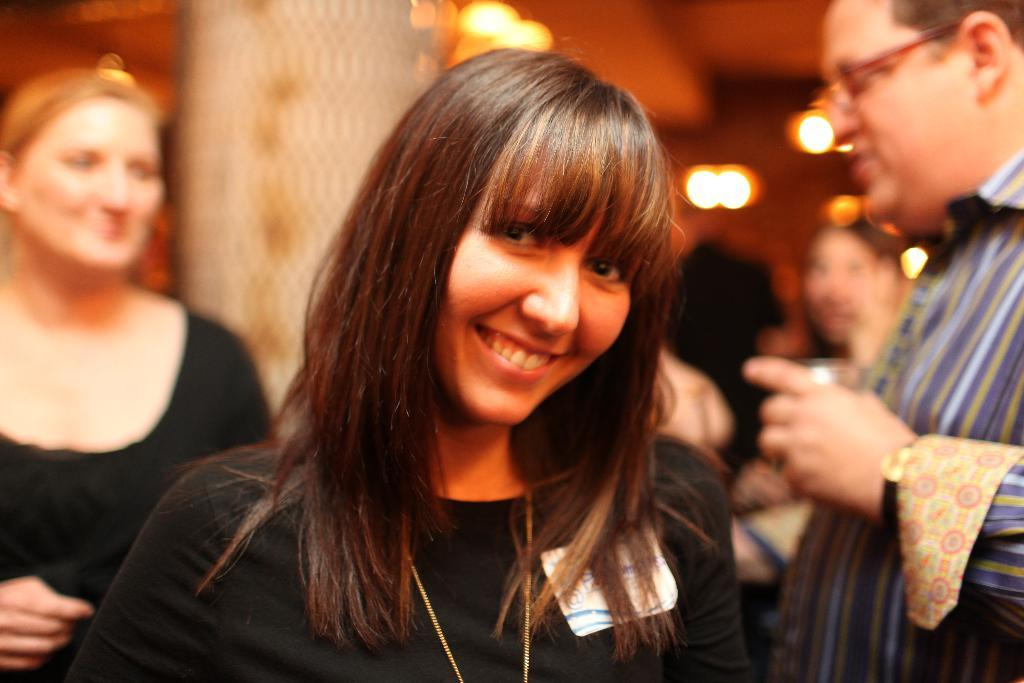What can be observed about the people in the image? There are both men and women in the image. Can you describe the position of the woman in the image? A woman is in the front of the image. What is the woman's facial expression in the image? The woman is smiling. What is the woman wearing in the image? The woman is wearing a black dress. What can be seen at the top of the image? There are lights at the top of the image. What date is marked on the calendar in the image? There is no calendar present in the image. What type of crops is the farmer harvesting in the image? There is no farmer or crops present in the image. 